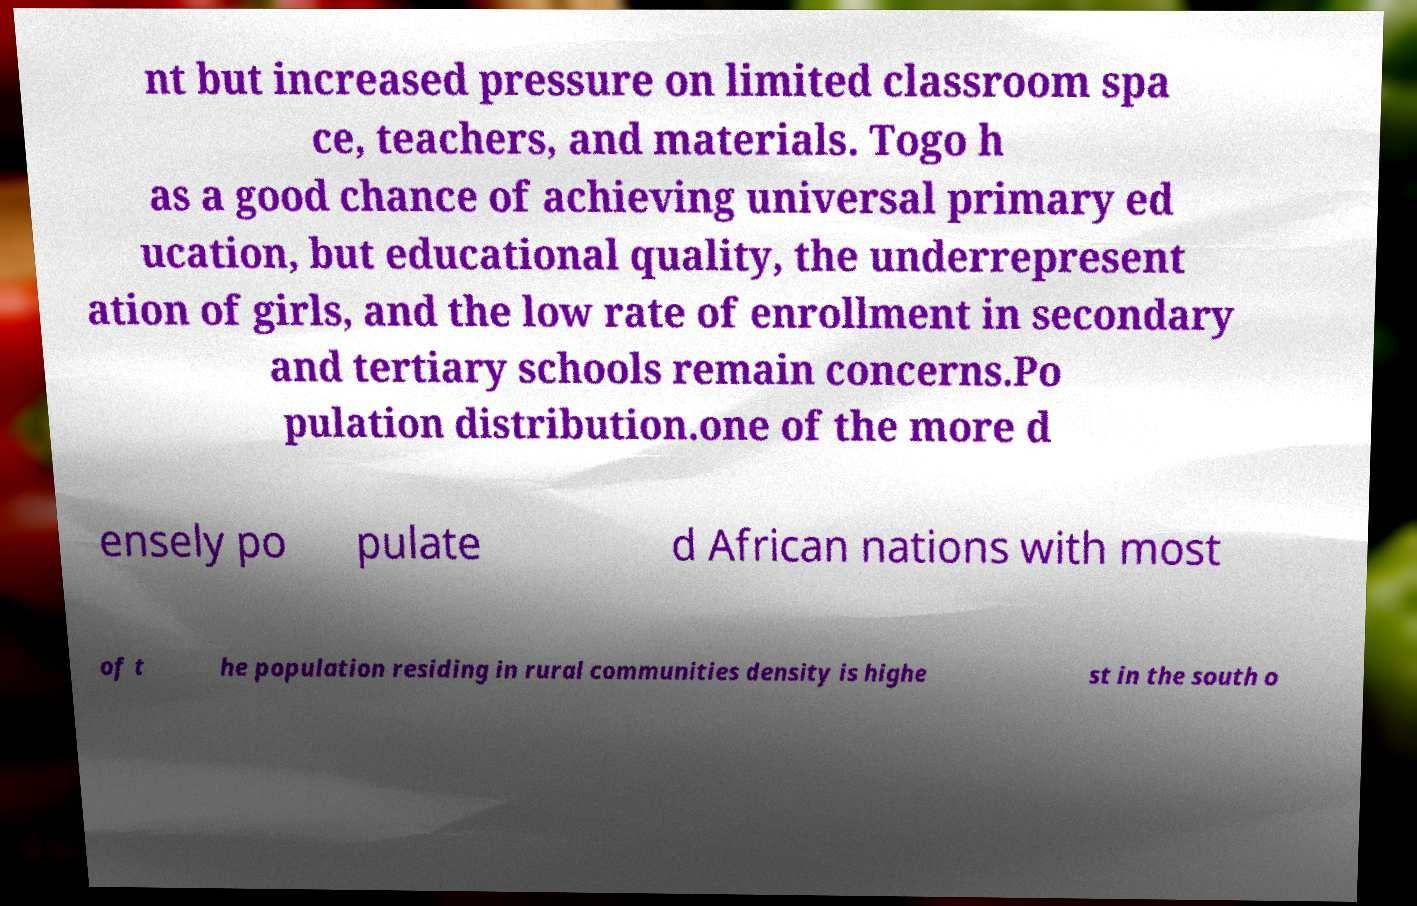Can you read and provide the text displayed in the image?This photo seems to have some interesting text. Can you extract and type it out for me? nt but increased pressure on limited classroom spa ce, teachers, and materials. Togo h as a good chance of achieving universal primary ed ucation, but educational quality, the underrepresent ation of girls, and the low rate of enrollment in secondary and tertiary schools remain concerns.Po pulation distribution.one of the more d ensely po pulate d African nations with most of t he population residing in rural communities density is highe st in the south o 